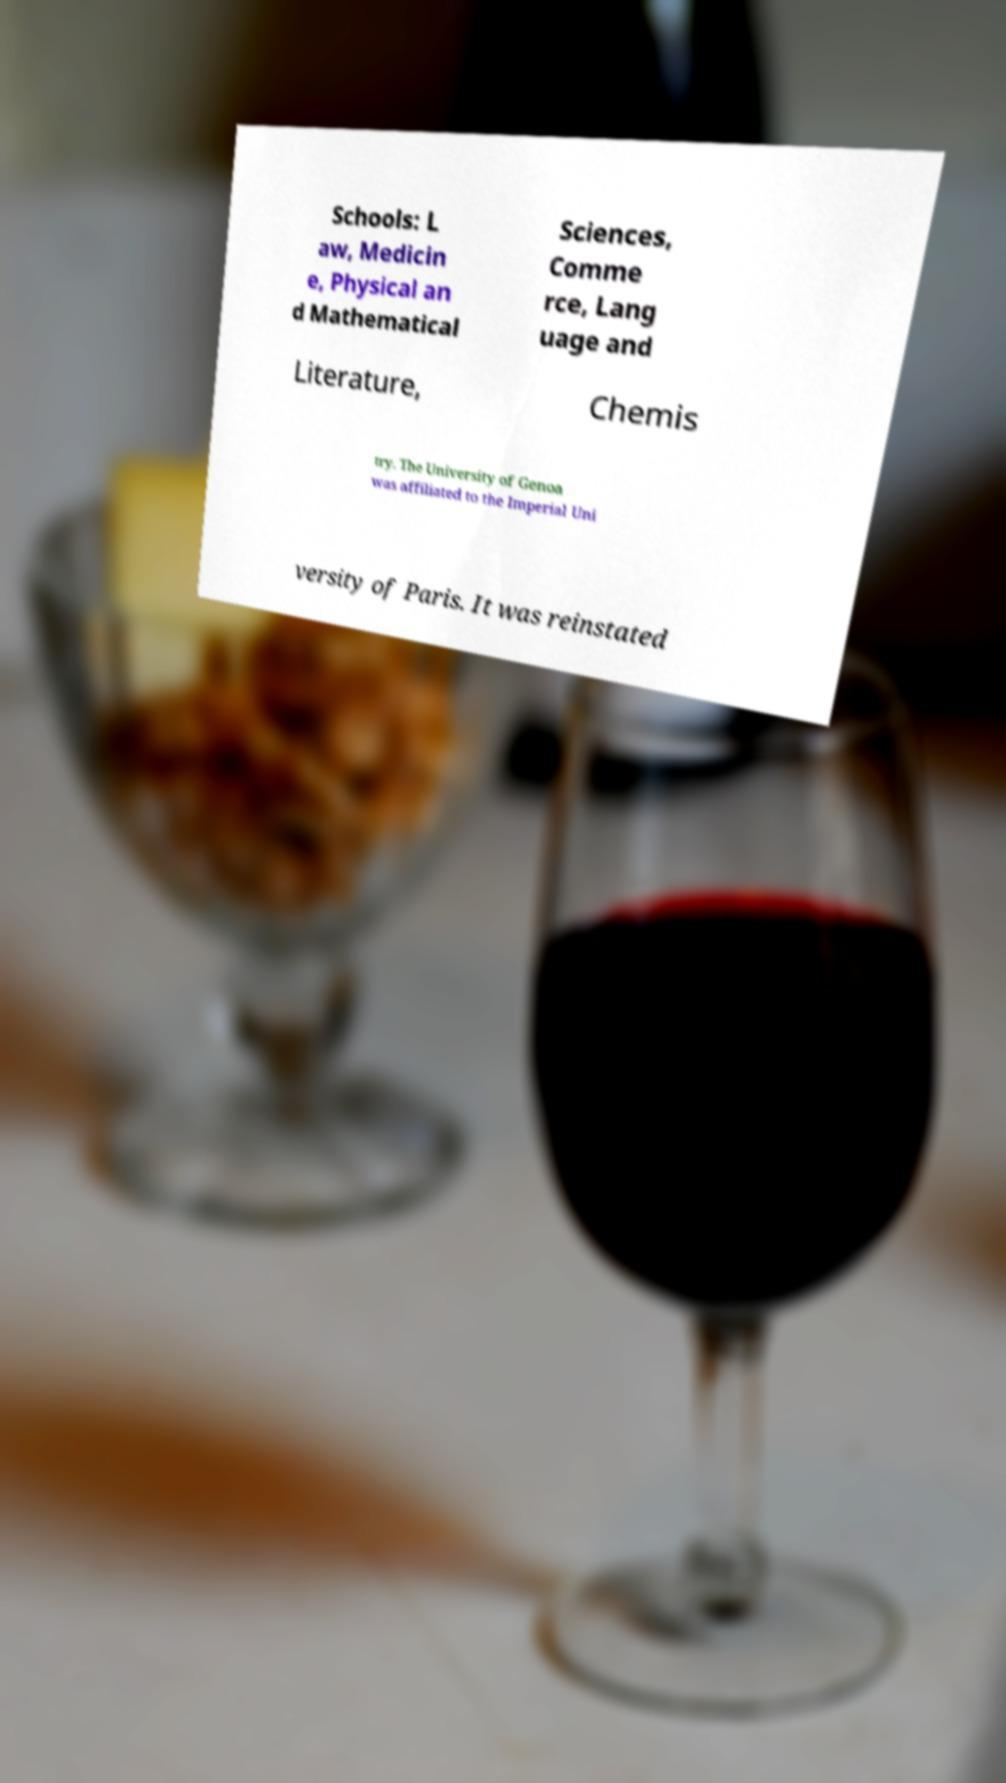Could you extract and type out the text from this image? Schools: L aw, Medicin e, Physical an d Mathematical Sciences, Comme rce, Lang uage and Literature, Chemis try. The University of Genoa was affiliated to the Imperial Uni versity of Paris. It was reinstated 